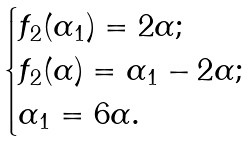<formula> <loc_0><loc_0><loc_500><loc_500>\begin{cases} f _ { 2 } ( \alpha _ { 1 } ) = 2 \alpha ; \\ f _ { 2 } ( \alpha ) = \alpha _ { 1 } - 2 \alpha ; \\ \alpha _ { 1 } = 6 \alpha . \end{cases}</formula> 